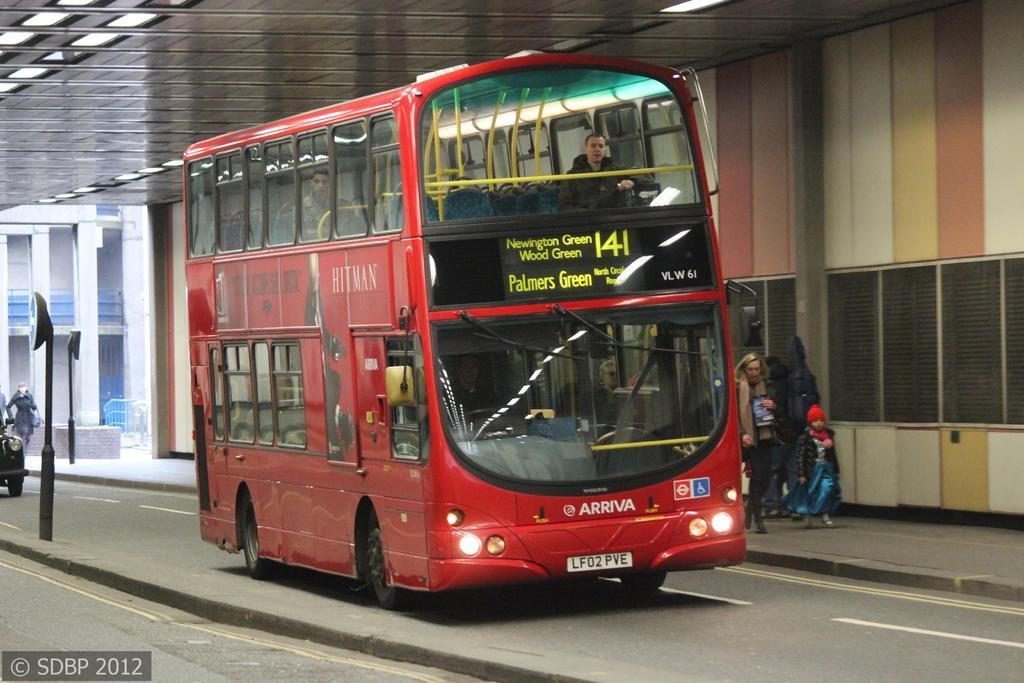Please provide a concise description of this image. In this picture we can see a few people in the bus. There are numbers, text and lights are visible on this bus. We can see a watermark and a text in the bottom left. There is a vehicle on the road. We can see a few black objects on the path. There are a few people visible on the path on the right side. We can see a building and other objects in the background. 